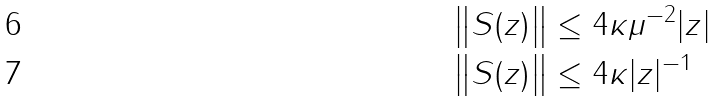<formula> <loc_0><loc_0><loc_500><loc_500>\left \| S ( z ) \right \| & \leq 4 \kappa \mu ^ { - 2 } | z | \\ \left \| S ( z ) \right \| & \leq 4 \kappa | z | ^ { - 1 }</formula> 